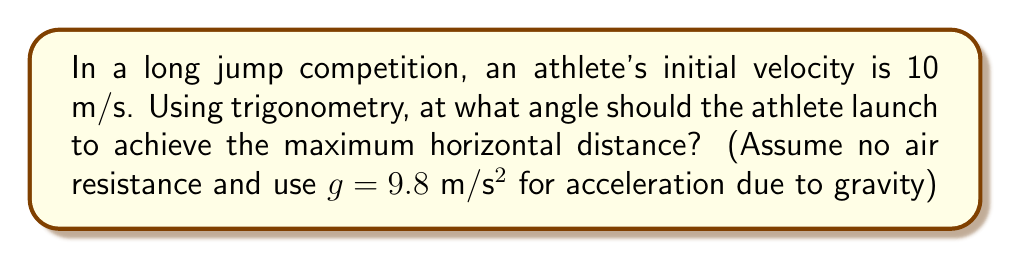Help me with this question. To find the optimal angle for a long jump, we need to use the principles of projectile motion and trigonometry. Let's approach this step-by-step:

1) The range (R) of a projectile launched at an angle θ with initial velocity v is given by:

   $$R = \frac{v^2 \sin(2θ)}{g}$$

2) To find the maximum range, we need to maximize $\sin(2θ)$. This occurs when $2θ = 90°$ or $θ = 45°$.

3) We can verify this mathematically:
   
   Let $y = \sin(2θ)$
   $$\frac{dy}{dθ} = 2\cos(2θ)$$

4) Setting this derivative to zero:
   
   $$2\cos(2θ) = 0$$
   $$\cos(2θ) = 0$$
   $$2θ = 90°$$
   $$θ = 45°$$

5) The second derivative is negative at this point, confirming it's a maximum.

Therefore, the optimal angle for the long jump, regardless of the initial velocity, is 45°.

This result is theoretical and assumes no air resistance. In practice, due to factors like air resistance and the athlete's running speed contributing to the horizontal component of velocity, the optimal angle is usually slightly less than 45°, typically around 20-25°.
Answer: 45° 